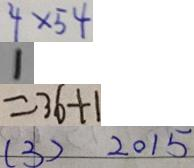<formula> <loc_0><loc_0><loc_500><loc_500>4 \times 5 4 
 1 
 = 3 6 + 1 
 ( 3 ) 2 0 1 5</formula> 